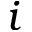Convert formula to latex. <formula><loc_0><loc_0><loc_500><loc_500>i</formula> 